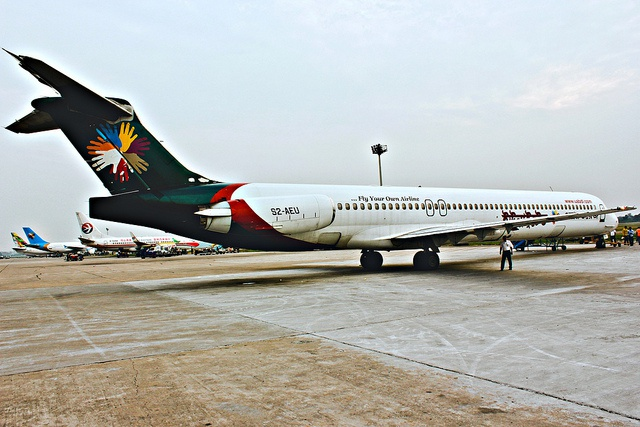Describe the objects in this image and their specific colors. I can see airplane in white, black, lightgray, darkgray, and gray tones, airplane in white, lightgray, black, darkgray, and gray tones, airplane in white, black, gray, and blue tones, airplane in white, black, lightblue, and gray tones, and airplane in white, black, lightgray, gray, and darkgray tones in this image. 